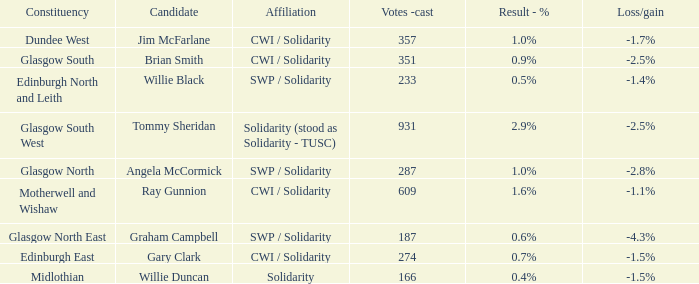Who was the candidate when the outcome was calculated as 2.9%? Tommy Sheridan. 